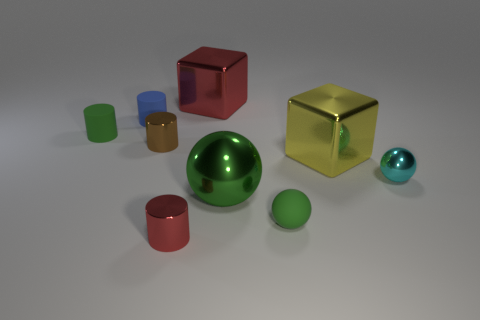Subtract all brown balls. Subtract all gray cylinders. How many balls are left? 3 Add 1 big metallic blocks. How many objects exist? 10 Subtract all balls. How many objects are left? 6 Subtract 0 purple blocks. How many objects are left? 9 Subtract all large red objects. Subtract all tiny green balls. How many objects are left? 7 Add 4 small red cylinders. How many small red cylinders are left? 5 Add 3 green shiny cubes. How many green shiny cubes exist? 3 